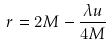Convert formula to latex. <formula><loc_0><loc_0><loc_500><loc_500>r = 2 M - \frac { \lambda u } { 4 M }</formula> 